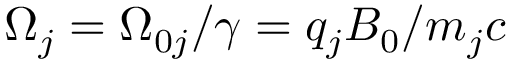<formula> <loc_0><loc_0><loc_500><loc_500>\Omega _ { j } = \Omega _ { 0 j } / \gamma = q _ { j } B _ { 0 } / m _ { j } c</formula> 